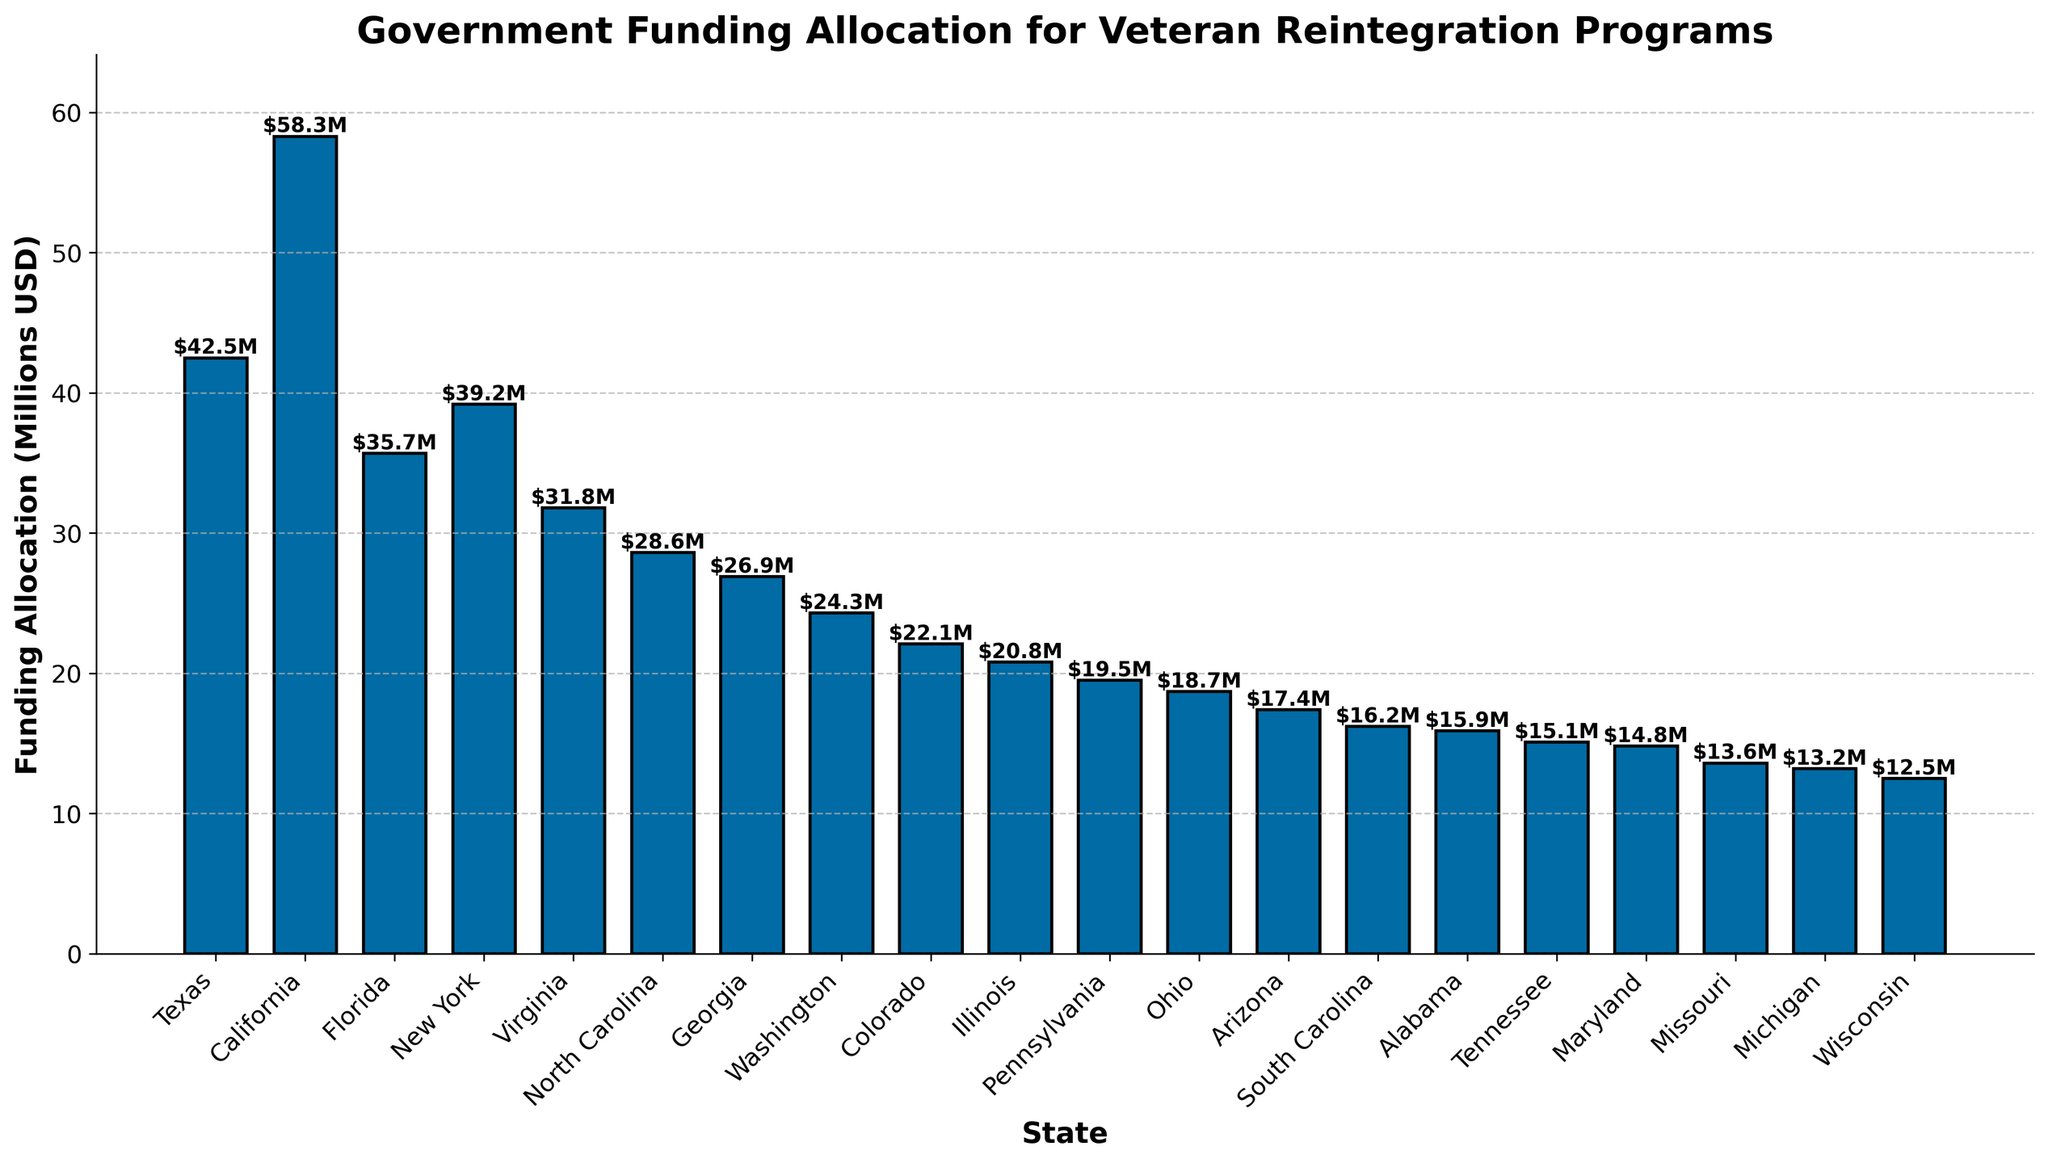What is the state with the highest funding allocation for veteran reintegration programs? To find the state with the highest funding allocation, look at the bar that reaches the highest on the y-axis. The state represented by this bar is California.
Answer: California What is the combined funding allocation of Texas and New York? Add the funding allocations of Texas and New York: Texas has $42.5 million and New York has $39.2 million. Thus, $42.5M + $39.2M = $81.7 million.
Answer: $81.7 million Which state has a funding allocation closest to $20 million? To determine the state closest to $20 million, look for the bar that is closest to the 20 million mark on the y-axis. Illinois, with a funding allocation of $20.8 million, is the closest.
Answer: Illinois How much more funding does California receive compared to Ohio? Subtract Ohio's funding allocation from California's: California has $58.3 million and Ohio has $18.7 million. Thus, $58.3M - $18.7M = $39.6 million.
Answer: $39.6 million Rank the top three states in funding allocation. Identify the three highest bars to determine the states with the highest values. The top three states are California ($58.3M), Texas ($42.5M), and New York ($39.2M).
Answer: 1. California, 2. Texas, 3. New York What is the average funding allocation across all states listed? Sum all the funding allocations and divide by the number of states: ($42.5M + $58.3M + $35.7M + $39.2M + $31.8M + $28.6M + $26.9M + $24.3M + $22.1M + $20.8M + $19.5M + $18.7M + $17.4M + $16.2M + $15.9M + $15.1M + $14.8M + $13.6M + $13.2M + $12.5M) / 20 = $27.72M.
Answer: $27.72 million Which states receive less than $15 million in funding allocation? Check the height of the bars to identify those below the $15 million mark. The states are Michigan ($13.2M) and Wisconsin ($12.5M).
Answer: Michigan, Wisconsin Compare the funding allocation between Virginia and North Carolina. Virginia has a funding allocation of $31.8M, and North Carolina has $28.6M. Virginia receives more funding than North Carolina.
Answer: Virginia receives more What is the total funding allocation for states with more than $30 million? Sum the funding for states with allocations above $30M: California ($58.3M), Texas ($42.5M), New York ($39.2M), Virginia ($31.8M), Florida ($35.7M). Thus, $58.3M + $42.5M + $39.2M + $31.8M + $35.7M = $207.5M.
Answer: $207.5 million What is the difference between the highest and lowest funding allocations? Subtract the lowest funding allocation from the highest: California ($58.3M) - Wisconsin ($12.5M) = $45.8 million.
Answer: $45.8 million 